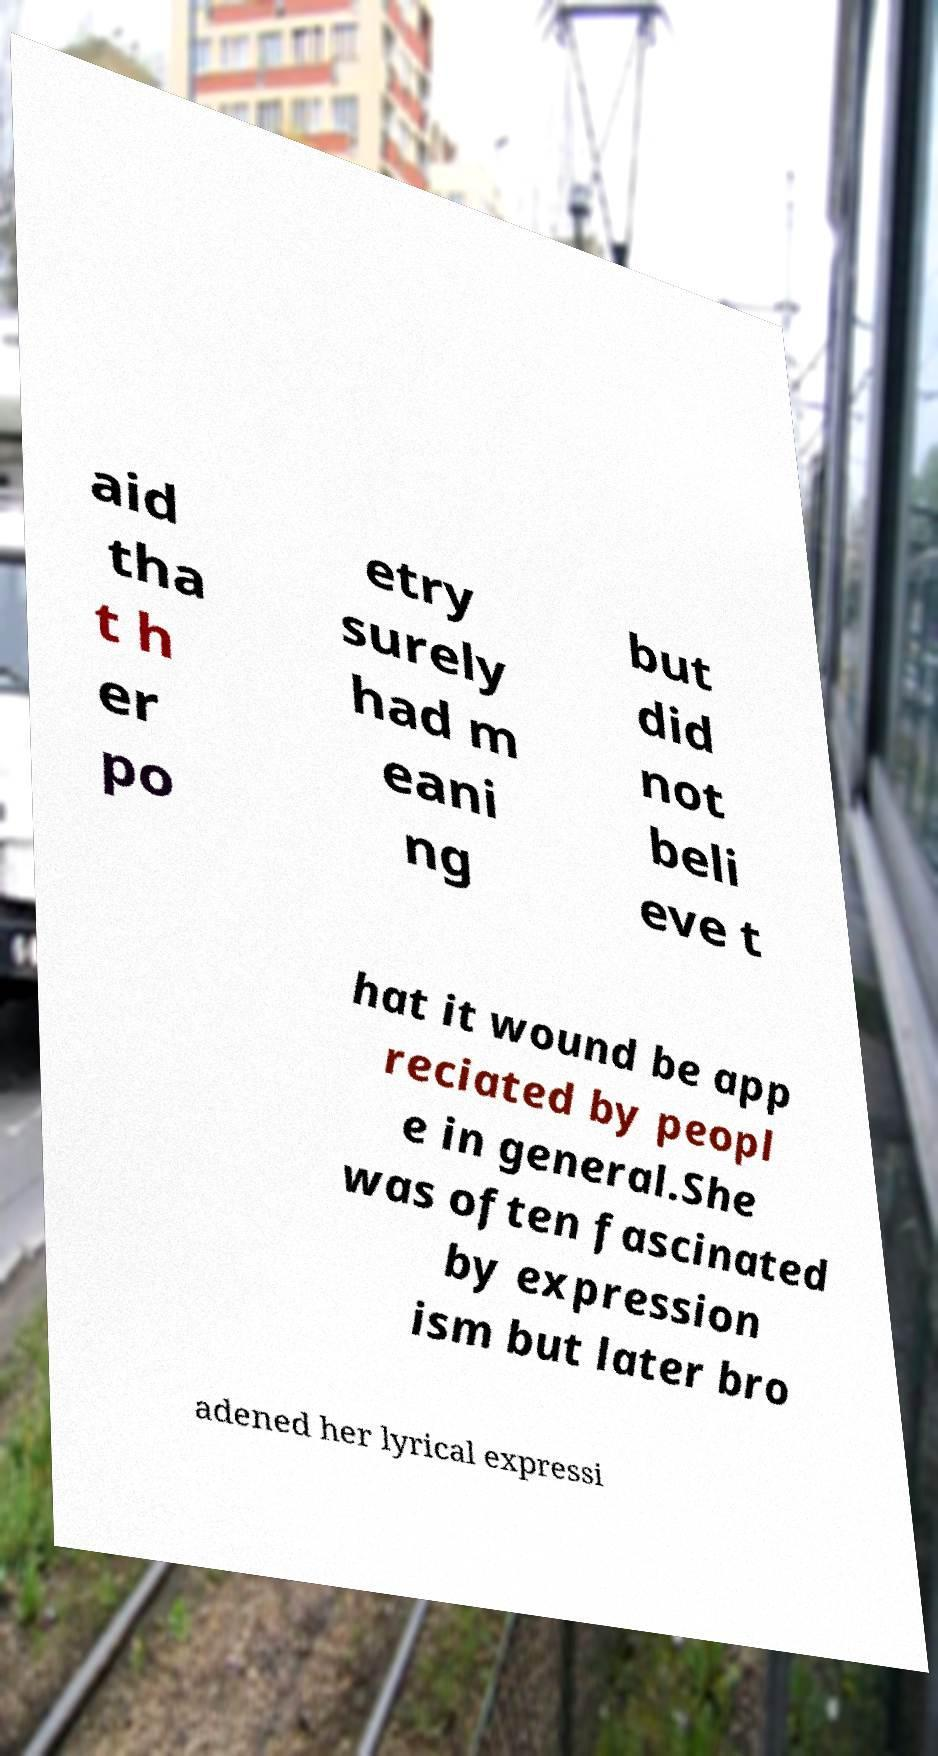What messages or text are displayed in this image? I need them in a readable, typed format. aid tha t h er po etry surely had m eani ng but did not beli eve t hat it wound be app reciated by peopl e in general.She was often fascinated by expression ism but later bro adened her lyrical expressi 